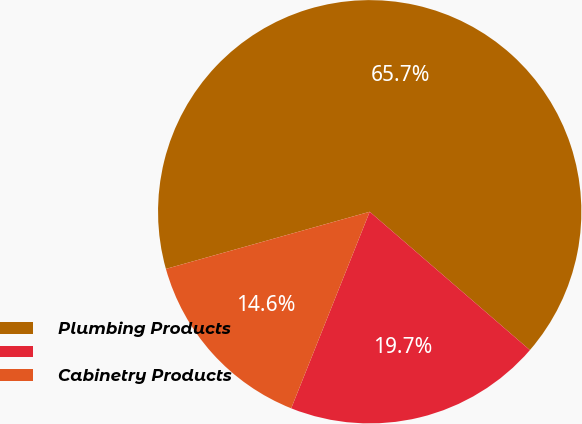Convert chart to OTSL. <chart><loc_0><loc_0><loc_500><loc_500><pie_chart><fcel>Plumbing Products<fcel>Unnamed: 1<fcel>Cabinetry Products<nl><fcel>65.69%<fcel>19.71%<fcel>14.6%<nl></chart> 